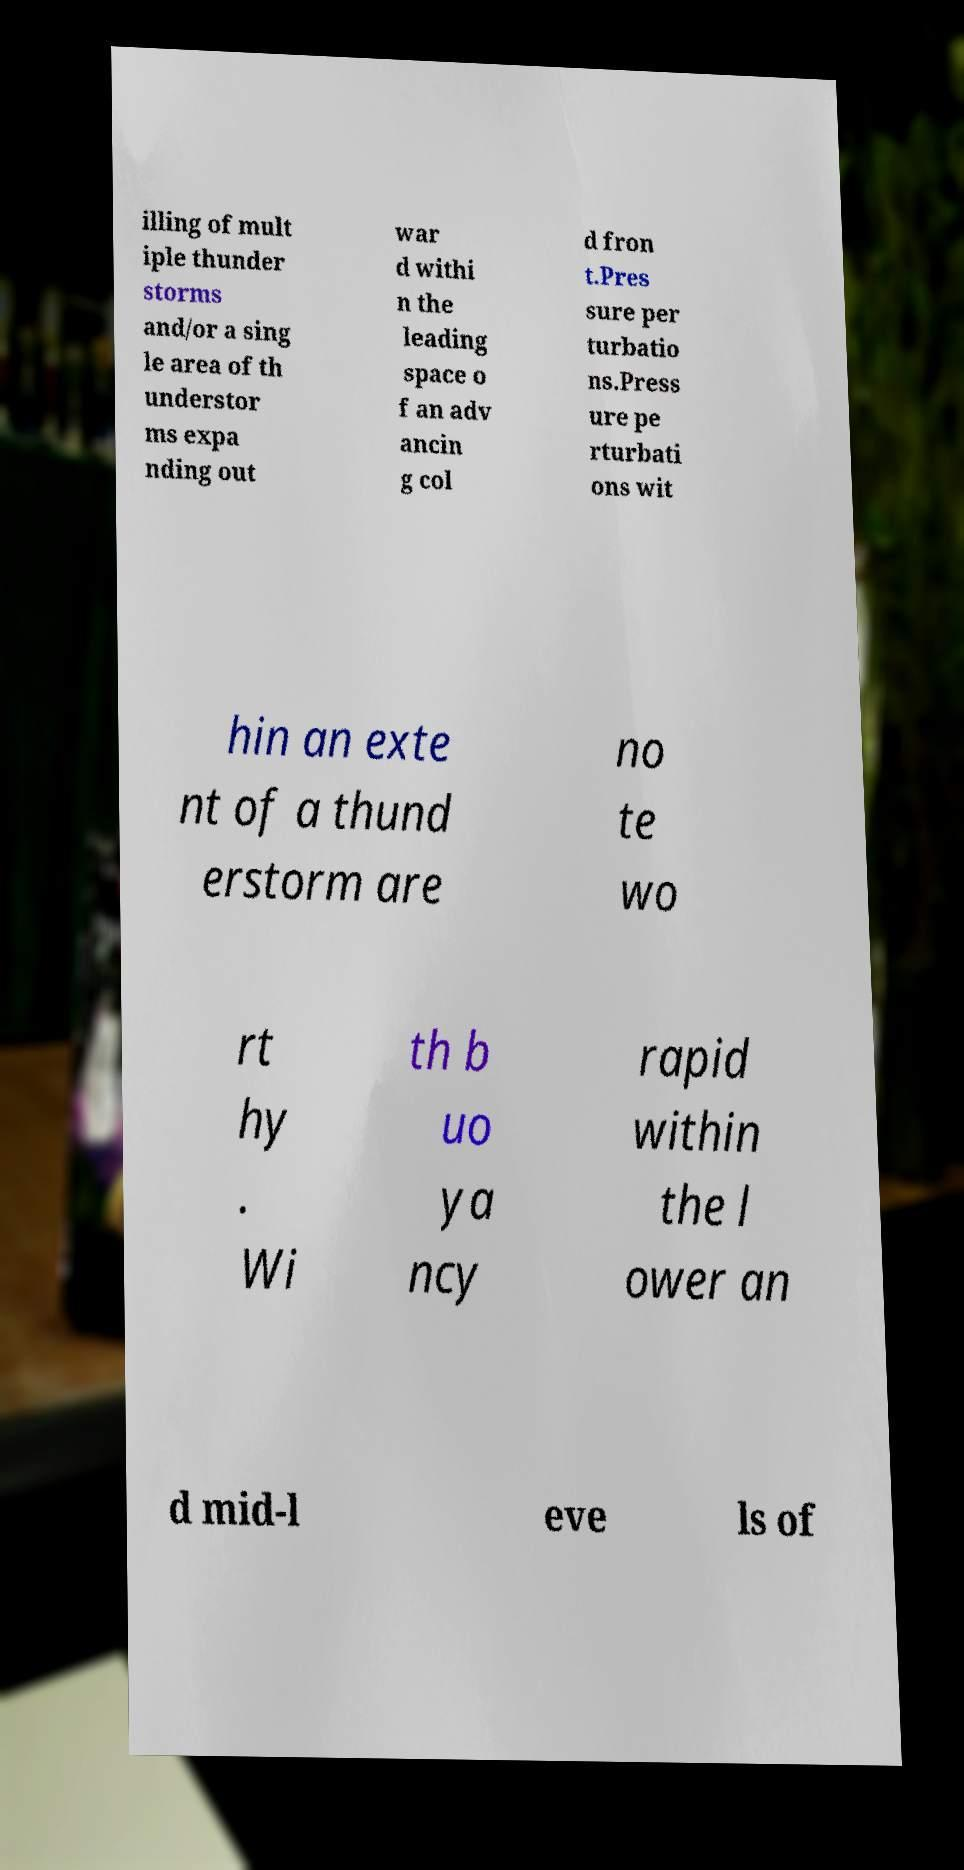For documentation purposes, I need the text within this image transcribed. Could you provide that? illing of mult iple thunder storms and/or a sing le area of th understor ms expa nding out war d withi n the leading space o f an adv ancin g col d fron t.Pres sure per turbatio ns.Press ure pe rturbati ons wit hin an exte nt of a thund erstorm are no te wo rt hy . Wi th b uo ya ncy rapid within the l ower an d mid-l eve ls of 